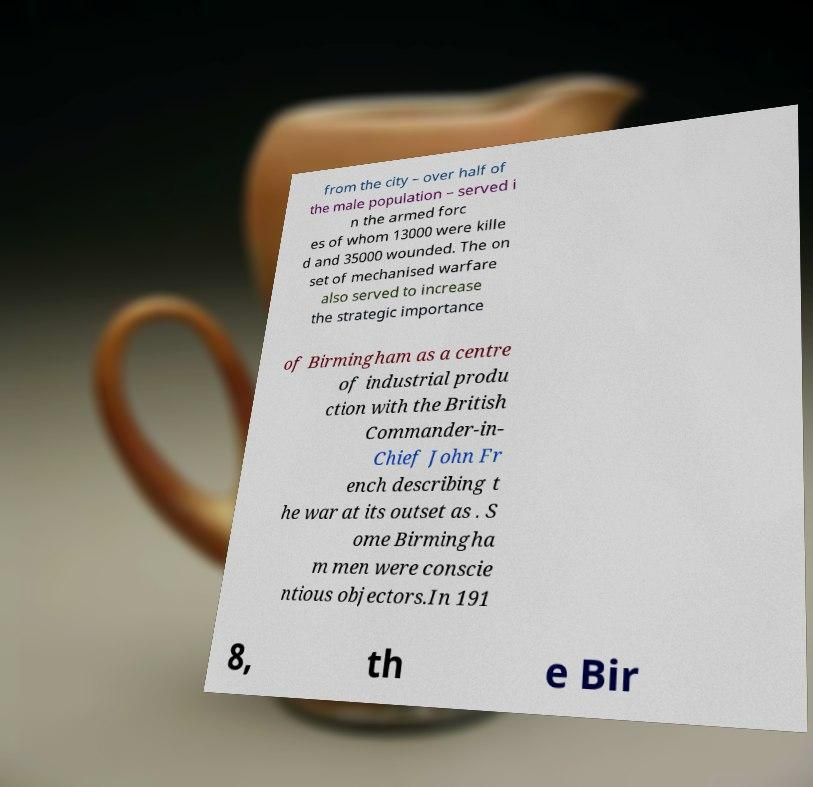For documentation purposes, I need the text within this image transcribed. Could you provide that? from the city – over half of the male population – served i n the armed forc es of whom 13000 were kille d and 35000 wounded. The on set of mechanised warfare also served to increase the strategic importance of Birmingham as a centre of industrial produ ction with the British Commander-in- Chief John Fr ench describing t he war at its outset as . S ome Birmingha m men were conscie ntious objectors.In 191 8, th e Bir 